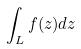<formula> <loc_0><loc_0><loc_500><loc_500>\int _ { L } f ( z ) d z</formula> 